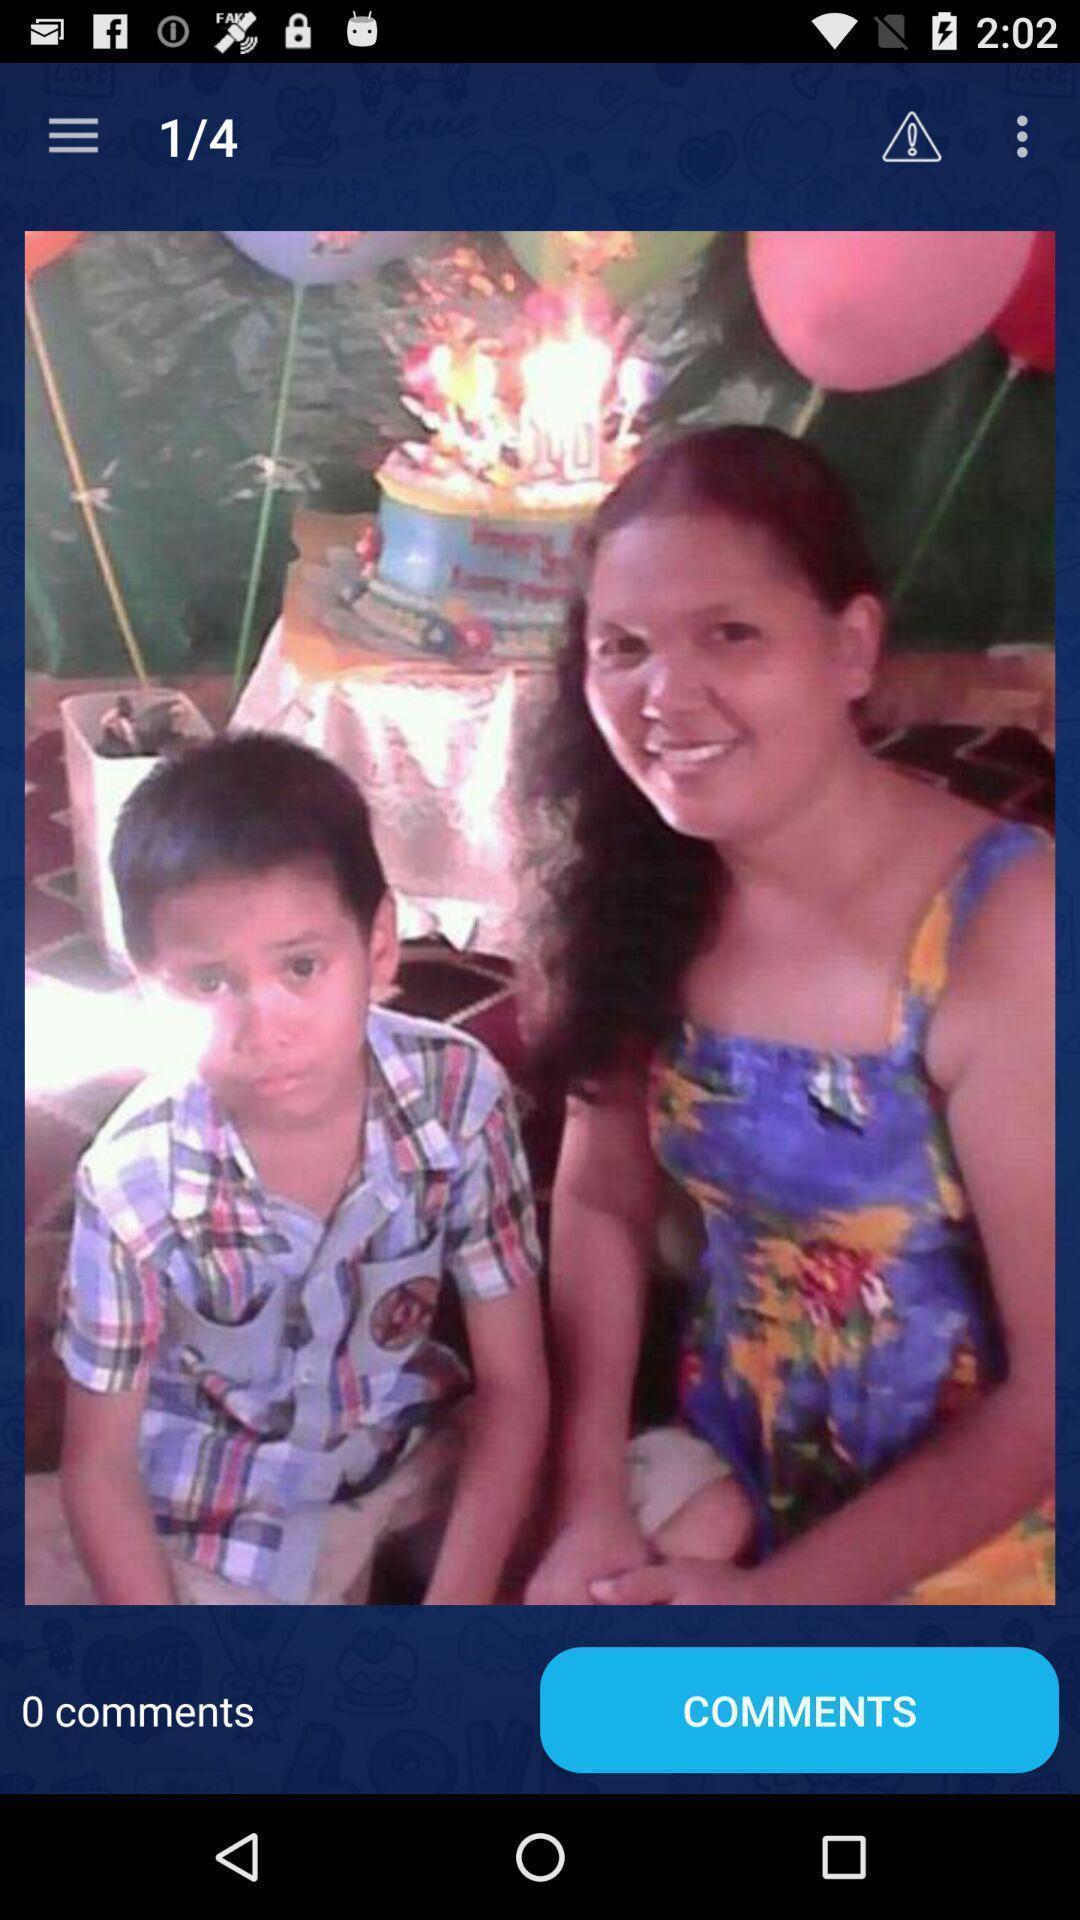Describe the visual elements of this screenshot. Page of an social application. 